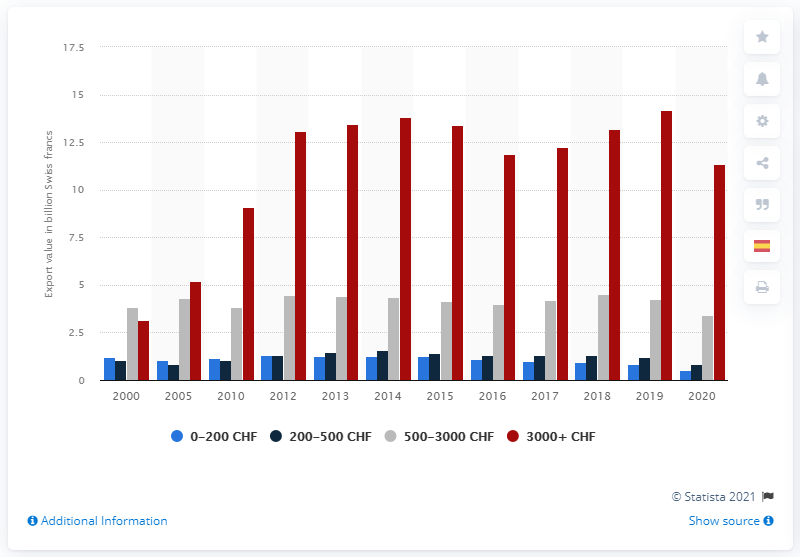List a handful of essential elements in this visual. In 2020, the export value of Swiss watches within the 0-200 CHF price category was 0.54 million. 